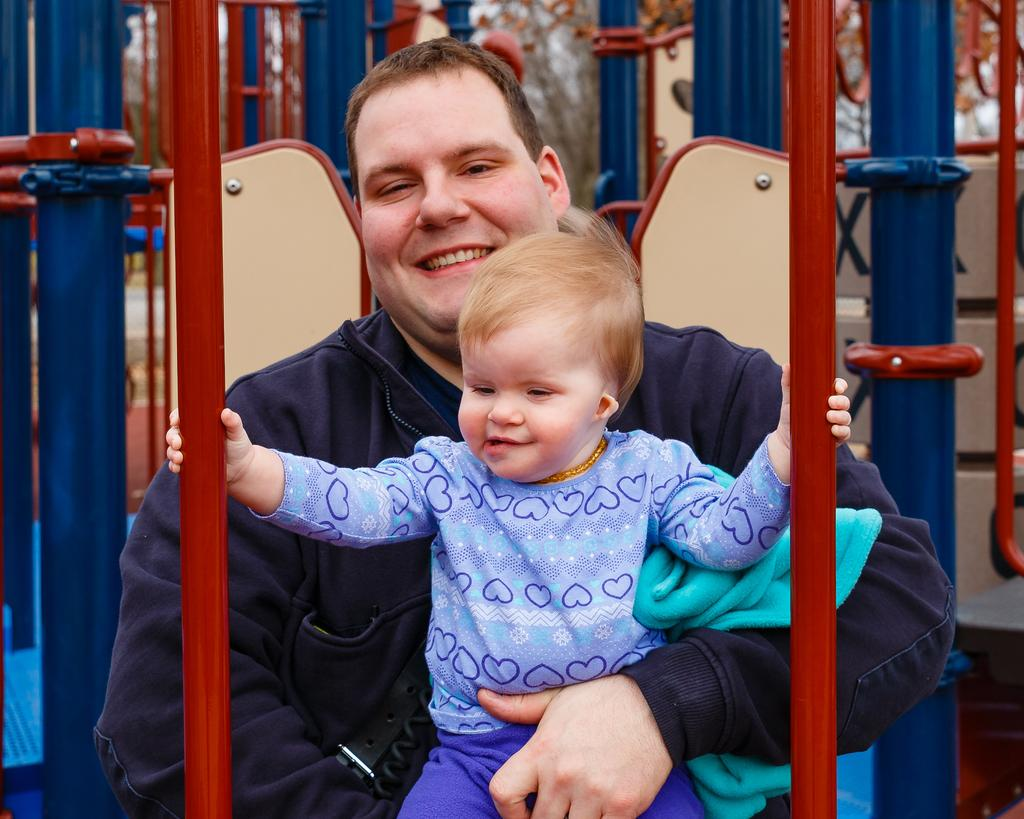Who is present in the image? There is a man and a child in the image. What is the man doing in the image? The man is smiling in the image. What is the child holding in the image? The child is holding rods in the image. What can be seen in the background of the image? There are trees in the background of the image. What type of fuel can be seen in the image? There is no fuel present in the image. Is there an alley visible in the image? There is no alley visible in the image. 